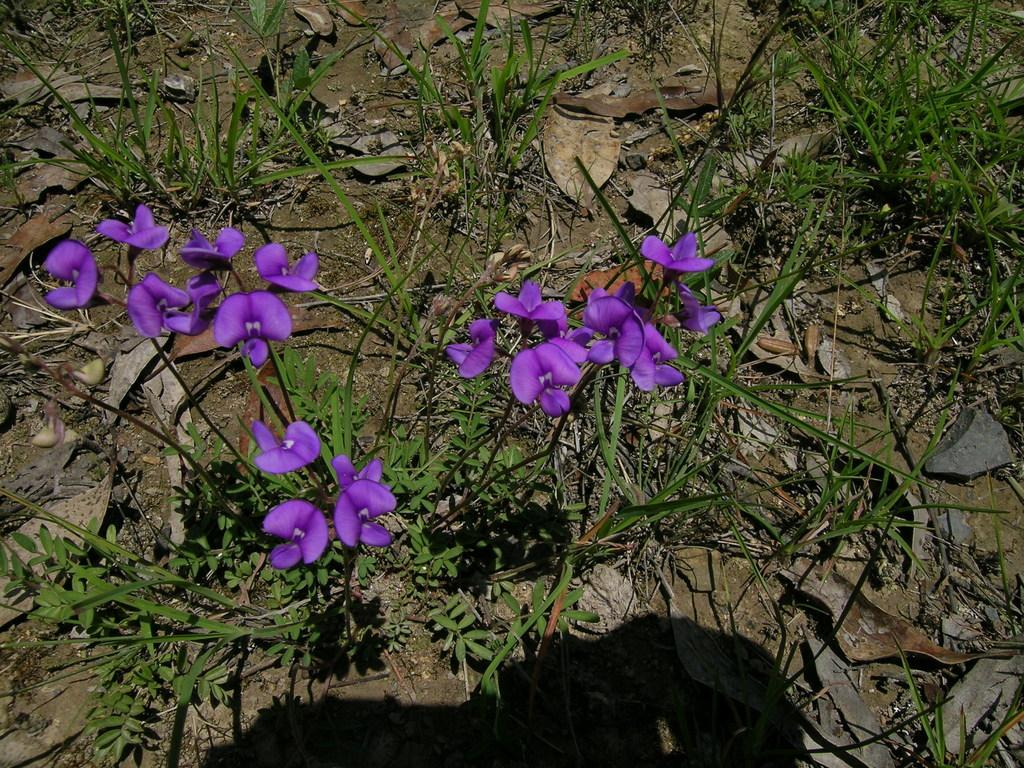What type of plants can be seen in the image? There are plants with flowers in the image. What can be found on the ground in the image? Dry leaves are present on the ground in the image. What type of baseball equipment can be seen in the image? There is no baseball equipment present in the image. 